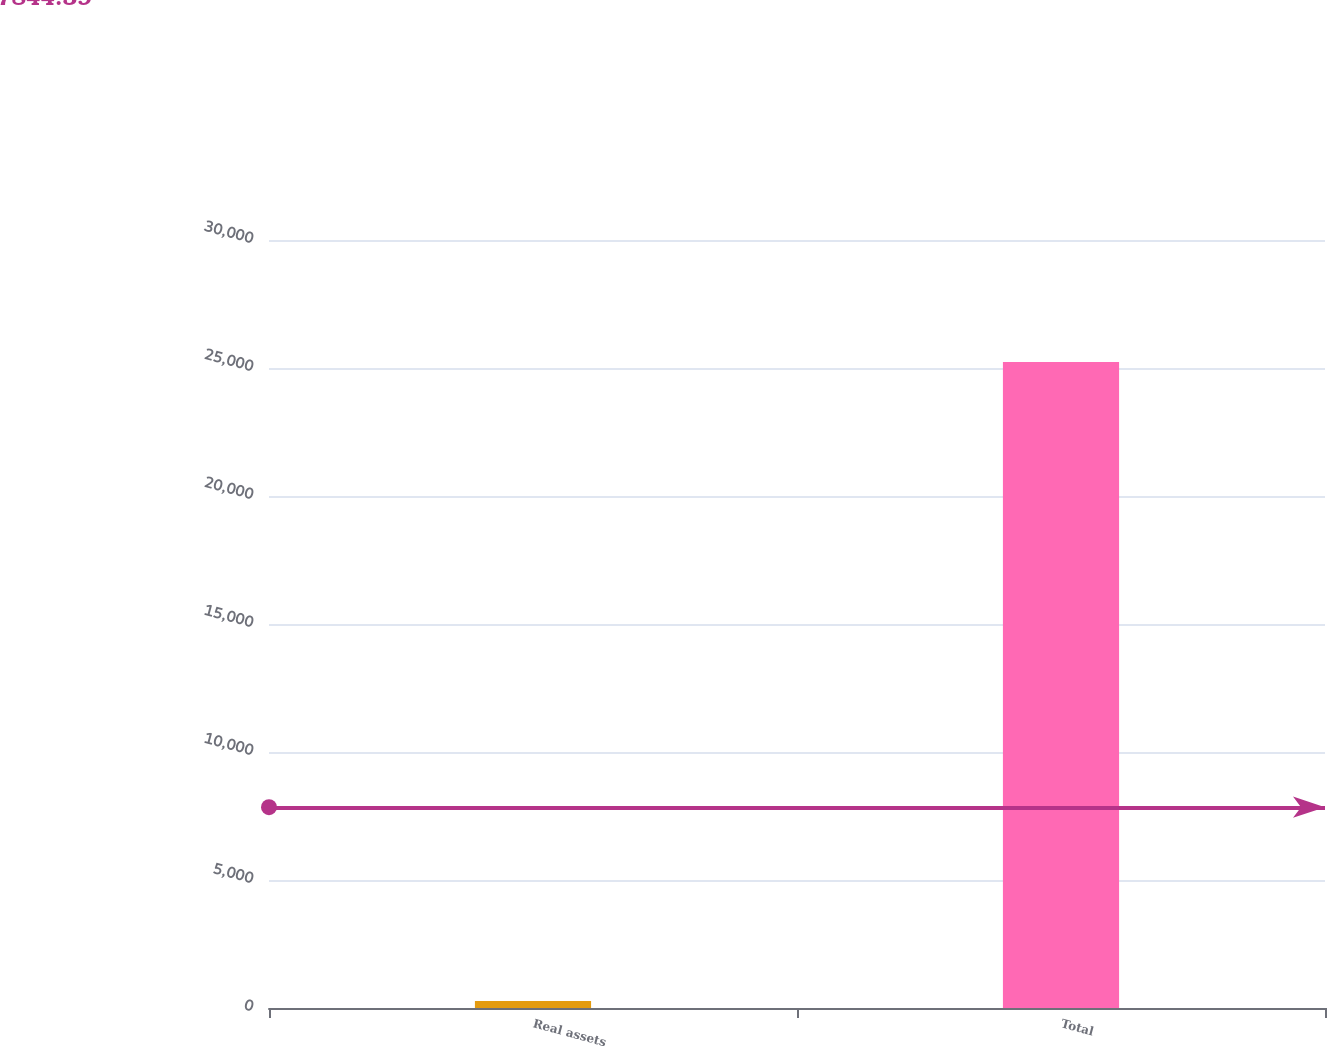Convert chart to OTSL. <chart><loc_0><loc_0><loc_500><loc_500><bar_chart><fcel>Real assets<fcel>Total<nl><fcel>275<fcel>25231<nl></chart> 